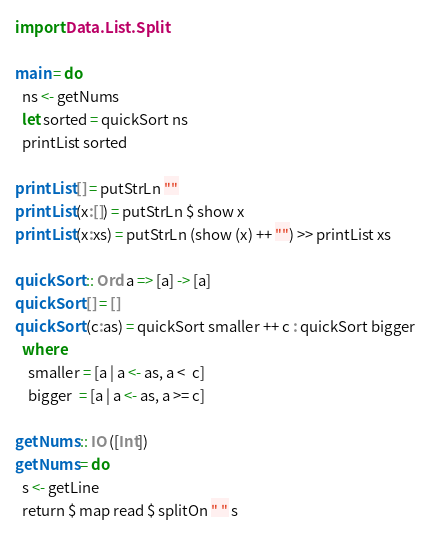<code> <loc_0><loc_0><loc_500><loc_500><_Haskell_>import Data.List.Split

main = do
  ns <- getNums
  let sorted = quickSort ns
  printList sorted

printList [] = putStrLn ""
printList (x:[]) = putStrLn $ show x
printList (x:xs) = putStrLn (show (x) ++ "") >> printList xs

quickSort :: Ord a => [a] -> [a]
quickSort [] = []
quickSort (c:as) = quickSort smaller ++ c : quickSort bigger
  where
    smaller = [a | a <- as, a <  c]
    bigger  = [a | a <- as, a >= c]

getNums :: IO ([Int])
getNums = do
  s <- getLine
  return $ map read $ splitOn " " s

</code> 